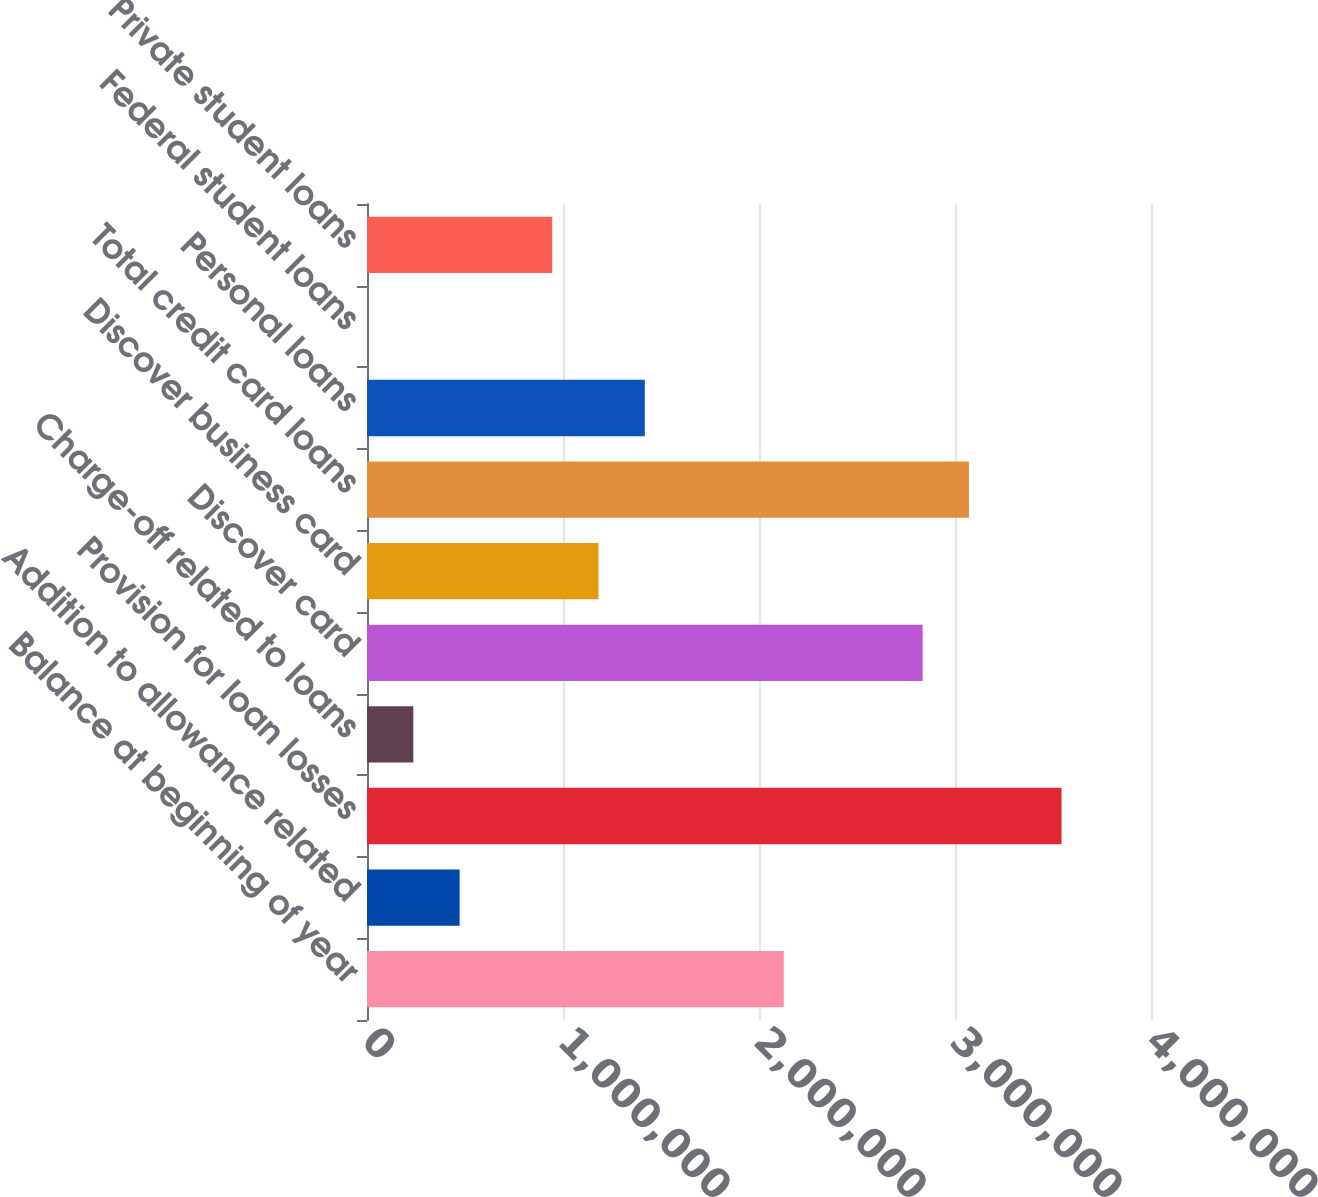Convert chart to OTSL. <chart><loc_0><loc_0><loc_500><loc_500><bar_chart><fcel>Balance at beginning of year<fcel>Addition to allowance related<fcel>Provision for loan losses<fcel>Charge-off related to loans<fcel>Discover card<fcel>Discover business card<fcel>Total credit card loans<fcel>Personal loans<fcel>Federal student loans<fcel>Private student loans<nl><fcel>2.12616e+06<fcel>472483<fcel>3.54361e+06<fcel>236242<fcel>2.83489e+06<fcel>1.1812e+06<fcel>3.07113e+06<fcel>1.41744e+06<fcel>2.05<fcel>944963<nl></chart> 